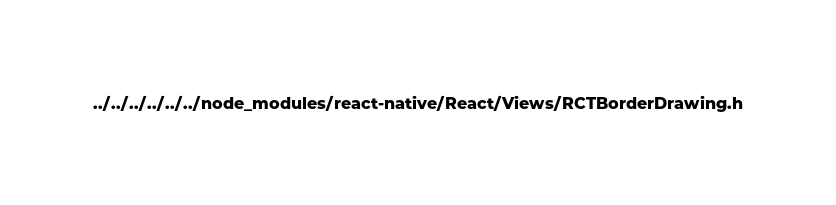Convert code to text. <code><loc_0><loc_0><loc_500><loc_500><_C_>../../../../../../node_modules/react-native/React/Views/RCTBorderDrawing.h</code> 